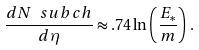<formula> <loc_0><loc_0><loc_500><loc_500>\frac { d N \ s u b { c h } } { d \eta } \approx . 7 4 \ln \left ( \frac { E _ { * } } { m } \right ) \, .</formula> 